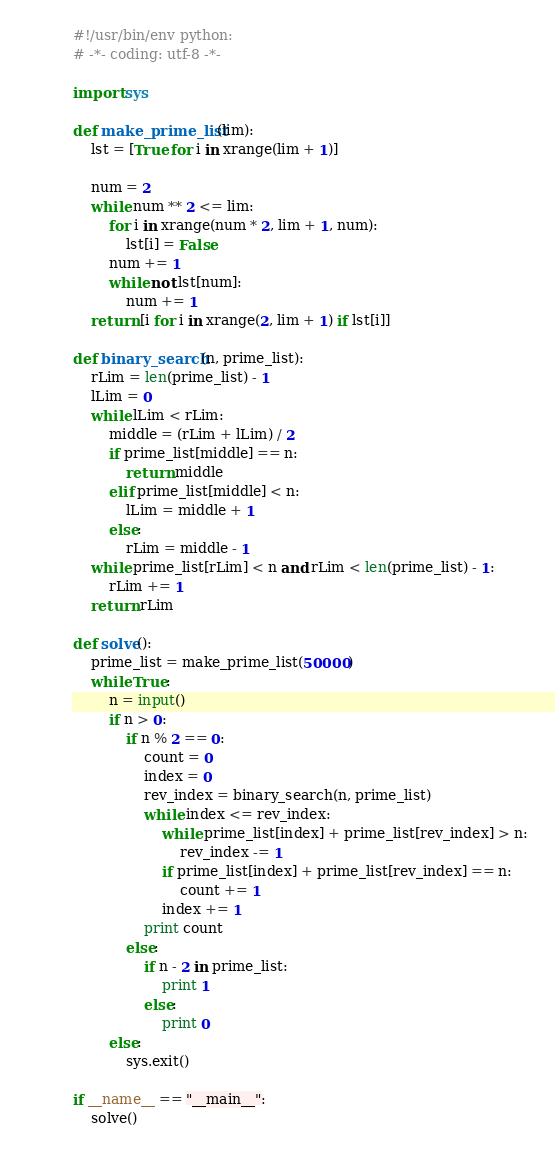<code> <loc_0><loc_0><loc_500><loc_500><_Python_>#!/usr/bin/env python:
# -*- coding: utf-8 -*-

import sys

def make_prime_list(lim):
    lst = [True for i in xrange(lim + 1)]

    num = 2
    while num ** 2 <= lim:
        for i in xrange(num * 2, lim + 1, num):
            lst[i] = False
        num += 1
        while not lst[num]:
            num += 1
    return [i for i in xrange(2, lim + 1) if lst[i]]

def binary_search(n, prime_list):
    rLim = len(prime_list) - 1
    lLim = 0
    while lLim < rLim:
        middle = (rLim + lLim) / 2
        if prime_list[middle] == n:
            return middle
        elif prime_list[middle] < n:
            lLim = middle + 1
        else:
            rLim = middle - 1
    while prime_list[rLim] < n and rLim < len(prime_list) - 1:
        rLim += 1
    return rLim    

def solve():
    prime_list = make_prime_list(50000)
    while True:
        n = input()
        if n > 0:
            if n % 2 == 0:
                count = 0
                index = 0
                rev_index = binary_search(n, prime_list)
                while index <= rev_index:
                    while prime_list[index] + prime_list[rev_index] > n:
                        rev_index -= 1
                    if prime_list[index] + prime_list[rev_index] == n:
                        count += 1
                    index += 1
                print count
            else:
                if n - 2 in prime_list:
                    print 1
                else:
                    print 0
        else:
            sys.exit()

if __name__ == "__main__":
    solve()    </code> 